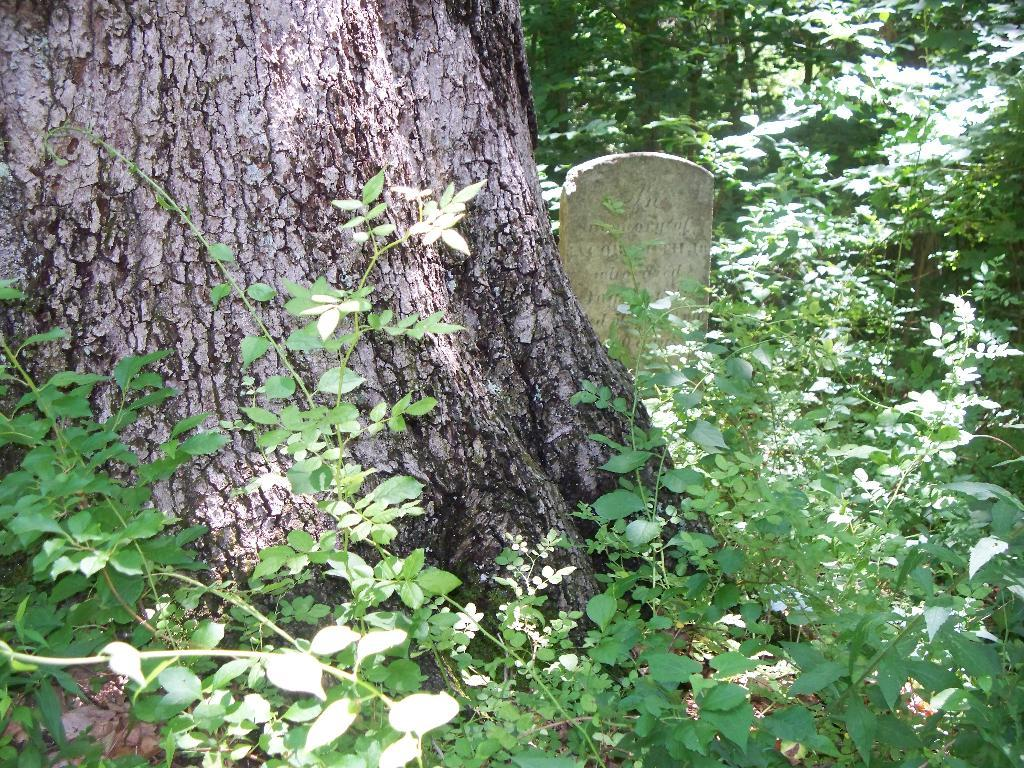What type of living organisms can be seen in the image? Plants and trees are visible in the image. Can you describe the natural setting visible in the image? The natural setting includes plants and trees. What is the rate of the volleyball game being played in the image? There is no volleyball game present in the image. What type of war is depicted in the image? There is no war depicted in the image; it features plants and trees. 